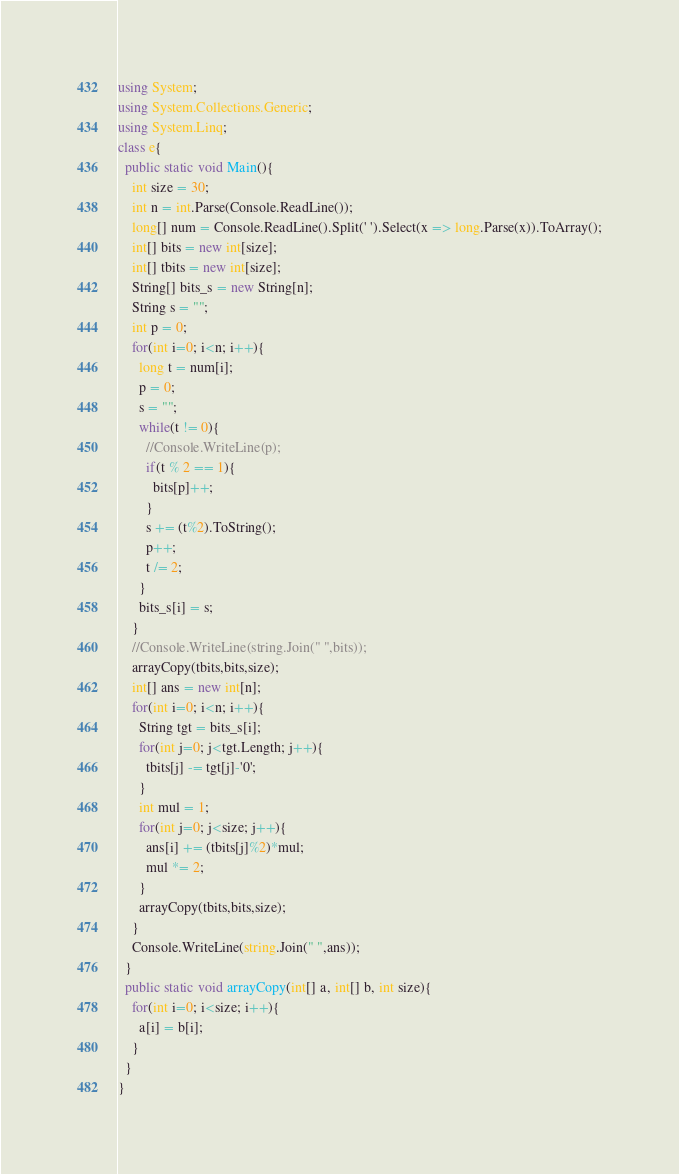Convert code to text. <code><loc_0><loc_0><loc_500><loc_500><_C#_>using System;
using System.Collections.Generic;
using System.Linq;
class e{
  public static void Main(){
    int size = 30;
    int n = int.Parse(Console.ReadLine());
    long[] num = Console.ReadLine().Split(' ').Select(x => long.Parse(x)).ToArray();
    int[] bits = new int[size];
    int[] tbits = new int[size];
    String[] bits_s = new String[n];
    String s = "";
    int p = 0;
    for(int i=0; i<n; i++){
      long t = num[i];
      p = 0;
      s = "";
      while(t != 0){
        //Console.WriteLine(p);
        if(t % 2 == 1){
          bits[p]++;
        }
        s += (t%2).ToString();
        p++;
        t /= 2;
      }
      bits_s[i] = s;
    }
    //Console.WriteLine(string.Join(" ",bits));
    arrayCopy(tbits,bits,size);
    int[] ans = new int[n];
    for(int i=0; i<n; i++){
      String tgt = bits_s[i];
      for(int j=0; j<tgt.Length; j++){
        tbits[j] -= tgt[j]-'0';
      }
      int mul = 1;
      for(int j=0; j<size; j++){
        ans[i] += (tbits[j]%2)*mul;
        mul *= 2;
      }
      arrayCopy(tbits,bits,size);
    }
    Console.WriteLine(string.Join(" ",ans));
  }
  public static void arrayCopy(int[] a, int[] b, int size){
    for(int i=0; i<size; i++){
      a[i] = b[i];
    }
  }
}
</code> 